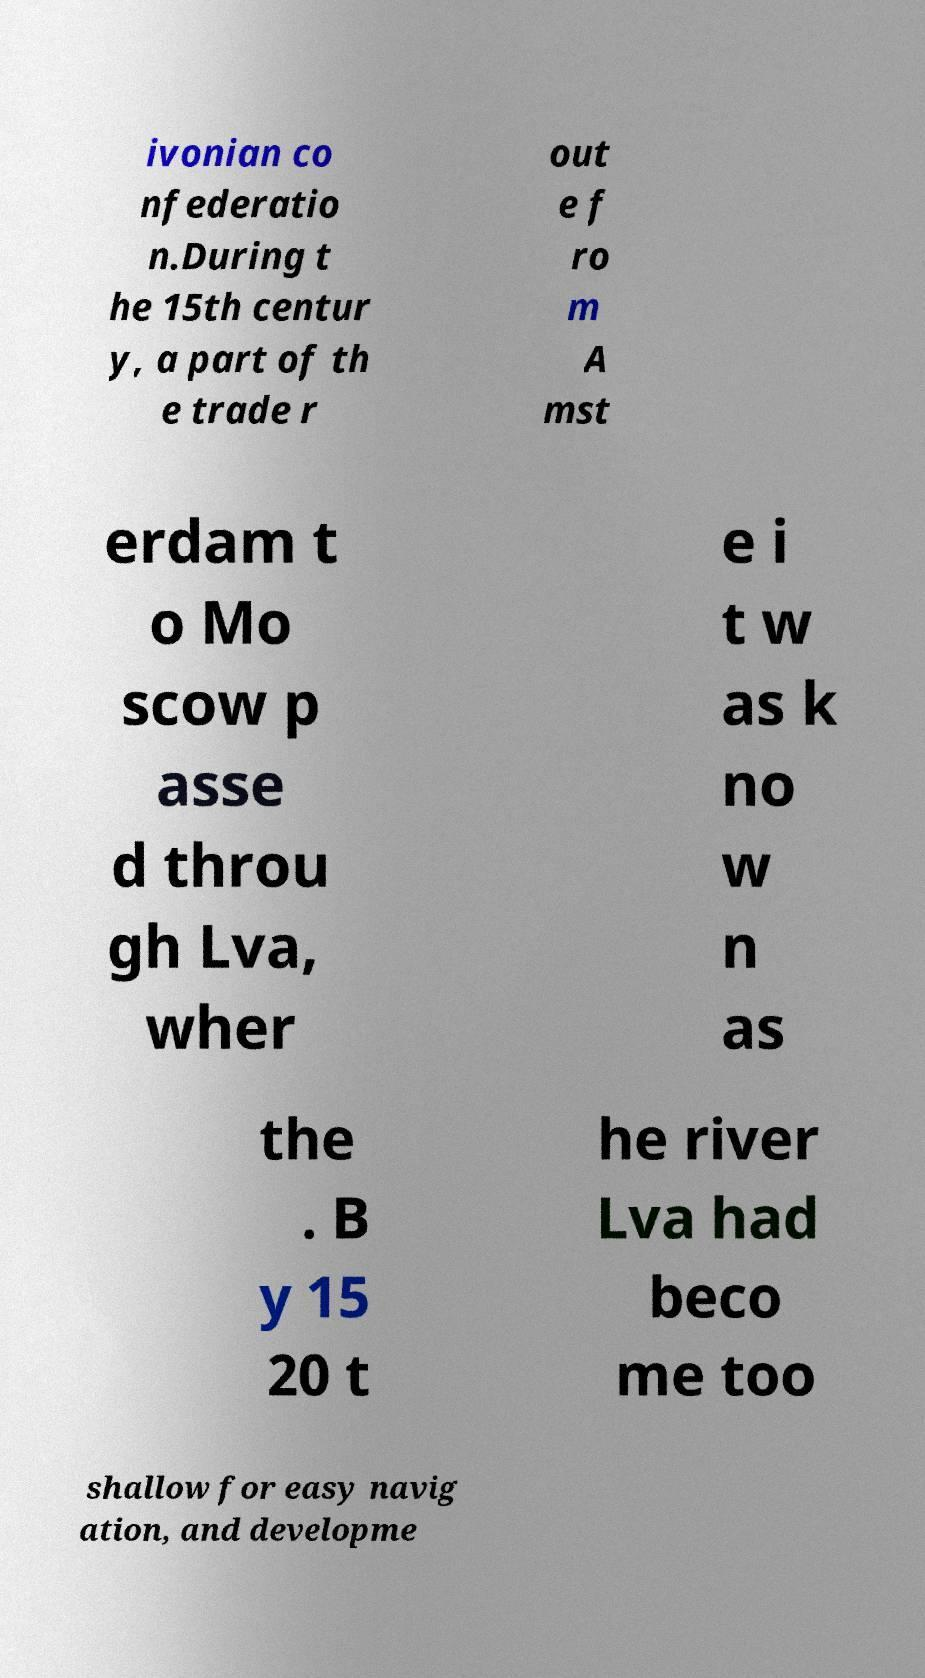I need the written content from this picture converted into text. Can you do that? ivonian co nfederatio n.During t he 15th centur y, a part of th e trade r out e f ro m A mst erdam t o Mo scow p asse d throu gh Lva, wher e i t w as k no w n as the . B y 15 20 t he river Lva had beco me too shallow for easy navig ation, and developme 